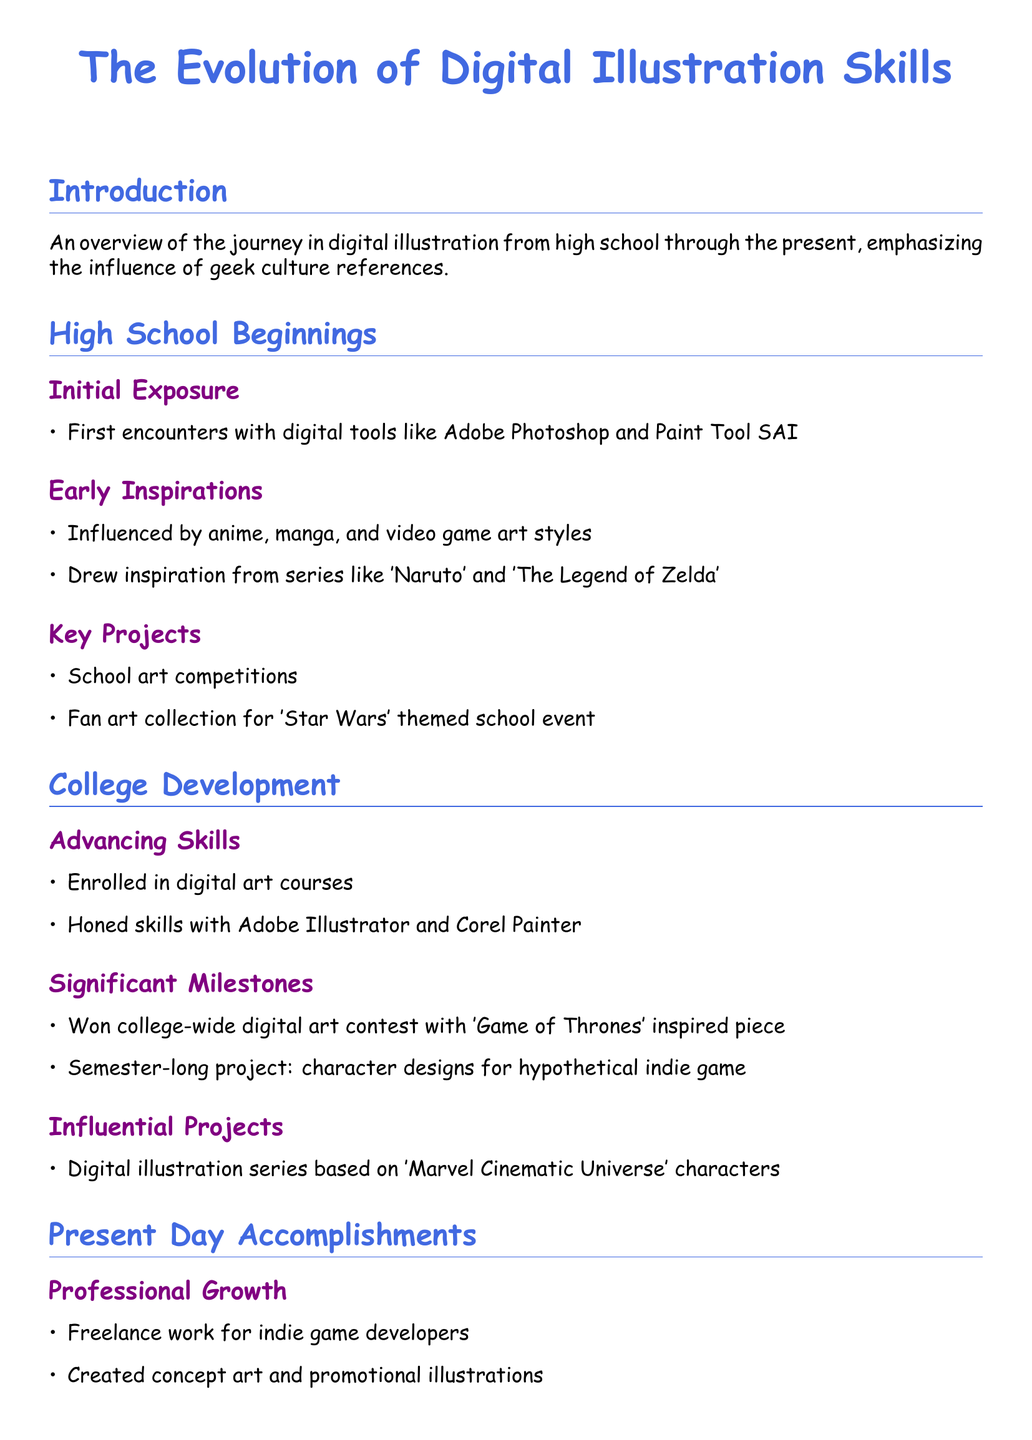What was the first digital tool you used? The document mentions Adobe Photoshop and Paint Tool SAI as the first digital tools encountered.
Answer: Adobe Photoshop and Paint Tool SAI Which anime influenced your early illustrations? The document states that 'Naruto' and 'The Legend of Zelda' were key inspirations.
Answer: Naruto and The Legend of Zelda What contest did you win in college? According to the document, you won a college-wide digital art contest with a piece inspired by 'Game of Thrones'.
Answer: 'Game of Thrones' inspired piece What type of project involved character designs? The document describes a semester-long project focused on character designs for a hypothetical indie game.
Answer: Character designs for hypothetical indie game What is a highlight from your portfolio? The document notes the notable fan art collection created for the 'Harry Potter' series as a highlight.
Answer: Fan art collection for 'Harry Potter' series How are you engaging with the art community? The document indicates that you are active on DeviantArt and ArtStation, and moderating a subreddit.
Answer: Active on DeviantArt and ArtStation What are your future aspirations? The document mentions goals to expand into 3D modeling and animation, specifically wanting to contribute to major franchises.
Answer: 3D modeling and animation During which educational phase did you enroll in digital art courses? The document specifies that you enrolled in digital art courses during college.
Answer: College 